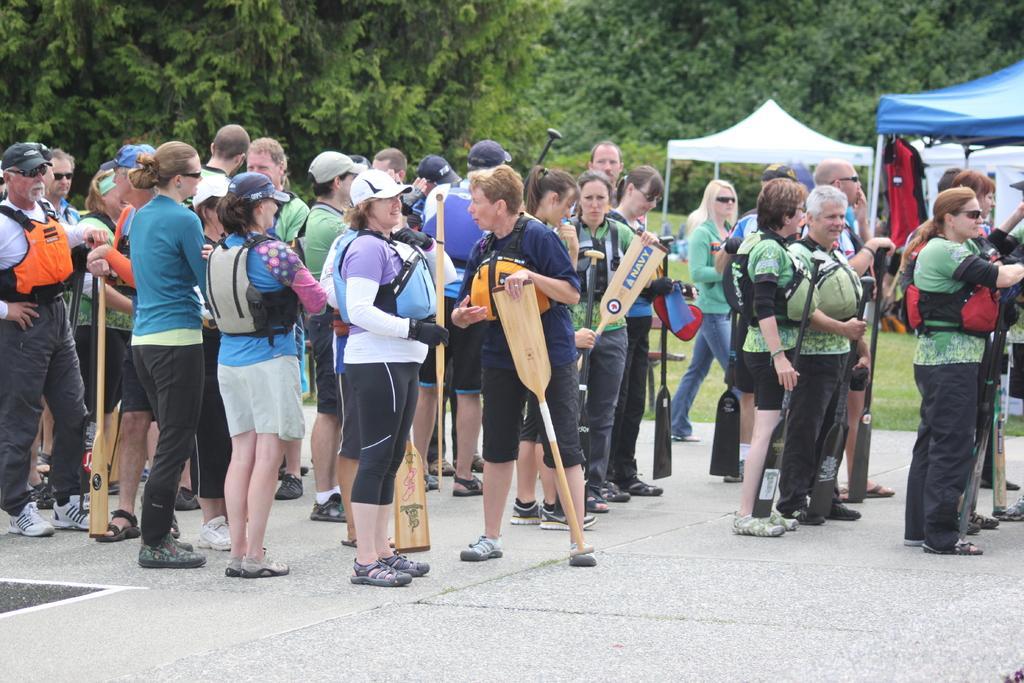How would you summarize this image in a sentence or two? In this image we can see group of people standing on the ground holding sticks in their hands. In the right side of the image we can see tents,clothes , and a bench. At the top of the image we can see group of trees. 